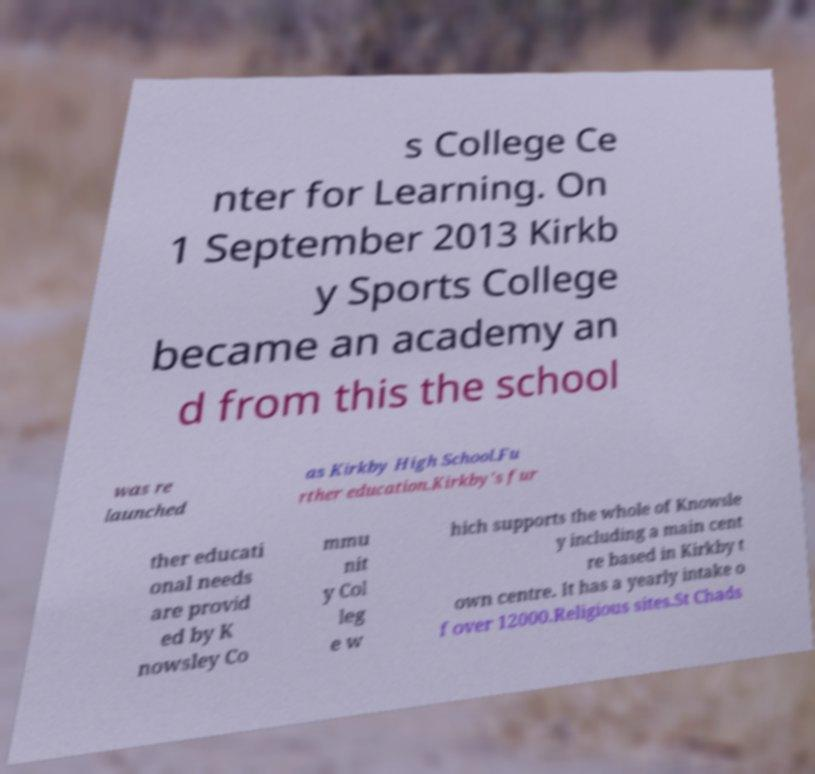Please read and relay the text visible in this image. What does it say? s College Ce nter for Learning. On 1 September 2013 Kirkb y Sports College became an academy an d from this the school was re launched as Kirkby High School.Fu rther education.Kirkby's fur ther educati onal needs are provid ed by K nowsley Co mmu nit y Col leg e w hich supports the whole of Knowsle y including a main cent re based in Kirkby t own centre. It has a yearly intake o f over 12000.Religious sites.St Chads 